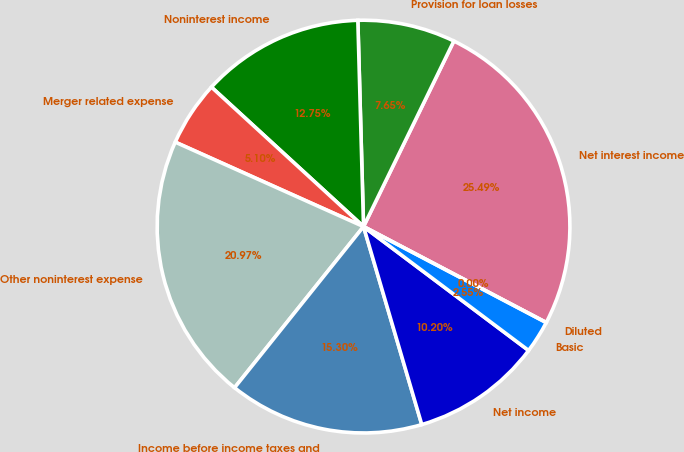<chart> <loc_0><loc_0><loc_500><loc_500><pie_chart><fcel>Net interest income<fcel>Provision for loan losses<fcel>Noninterest income<fcel>Merger related expense<fcel>Other noninterest expense<fcel>Income before income taxes and<fcel>Net income<fcel>Basic<fcel>Diluted<nl><fcel>25.49%<fcel>7.65%<fcel>12.75%<fcel>5.1%<fcel>20.97%<fcel>15.3%<fcel>10.2%<fcel>2.55%<fcel>0.0%<nl></chart> 